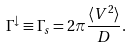<formula> <loc_0><loc_0><loc_500><loc_500>\Gamma ^ { \downarrow } \equiv \Gamma _ { s } = 2 \pi \frac { \langle V ^ { 2 } \rangle } { D } .</formula> 